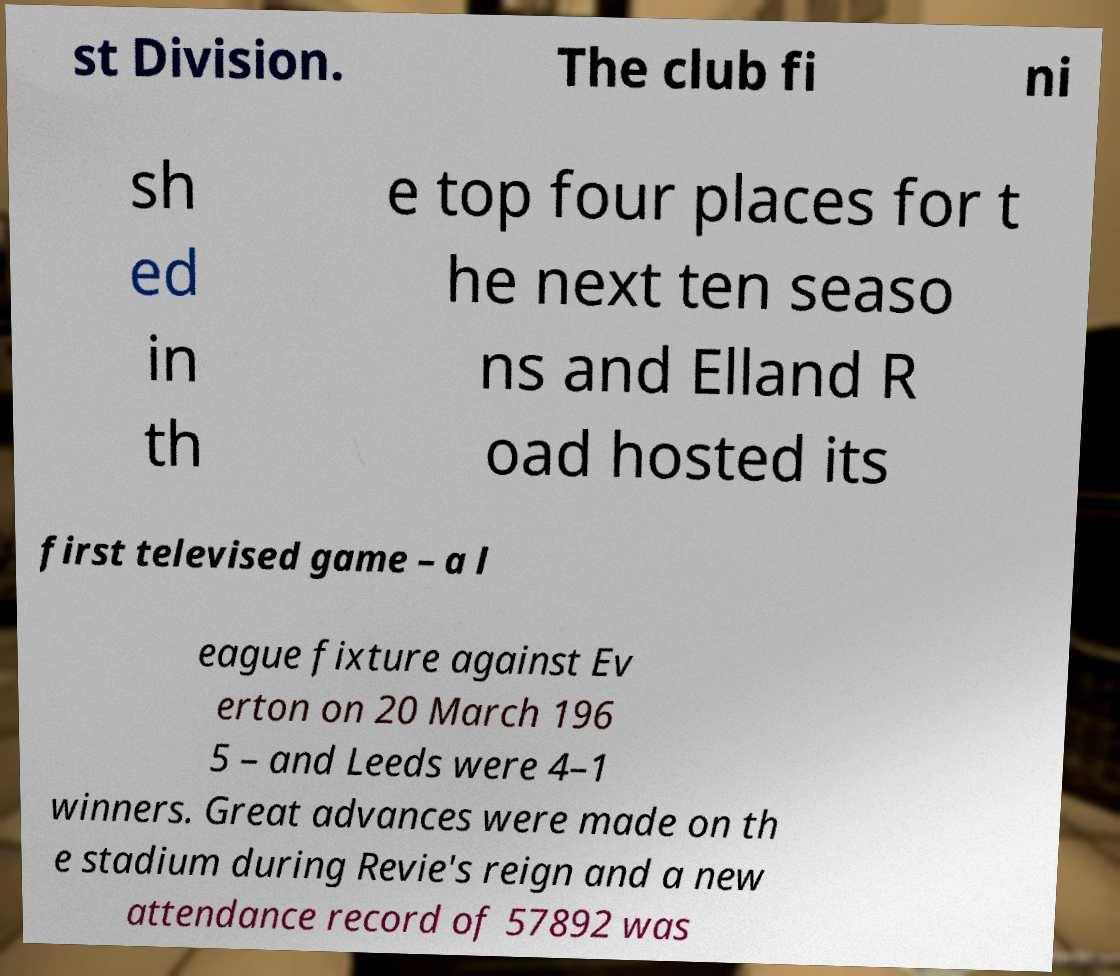Please read and relay the text visible in this image. What does it say? st Division. The club fi ni sh ed in th e top four places for t he next ten seaso ns and Elland R oad hosted its first televised game – a l eague fixture against Ev erton on 20 March 196 5 – and Leeds were 4–1 winners. Great advances were made on th e stadium during Revie's reign and a new attendance record of 57892 was 